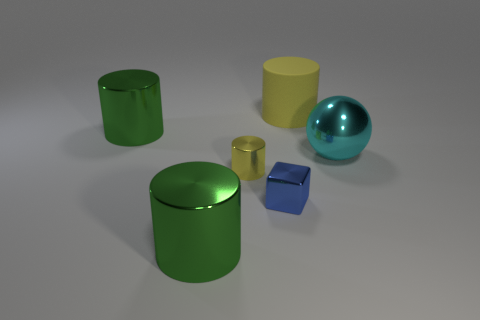Subtract all matte cylinders. How many cylinders are left? 3 Add 2 yellow cylinders. How many objects exist? 8 Subtract all yellow cylinders. How many cylinders are left? 2 Subtract all cylinders. How many objects are left? 2 Subtract 2 cylinders. How many cylinders are left? 2 Subtract all brown cubes. How many yellow cylinders are left? 2 Subtract all big cylinders. Subtract all large red blocks. How many objects are left? 3 Add 4 small yellow cylinders. How many small yellow cylinders are left? 5 Add 4 large green metallic things. How many large green metallic things exist? 6 Subtract 0 green cubes. How many objects are left? 6 